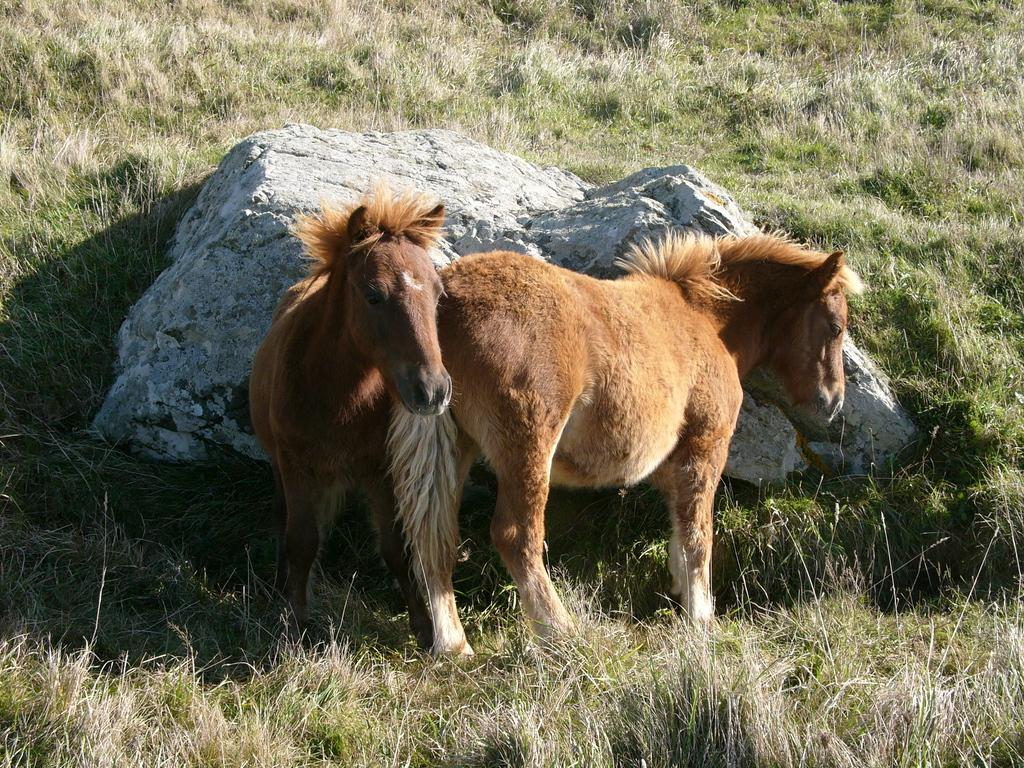How many horses are in the image? There are two horses in the image. What is the surface the horses are standing on? The horses are on the grass. What object are the horses leaning on? The horses are leaning on a rock. What type of advertisement can be seen on the horses in the image? There is no advertisement present on the horses in the image. What sound do the bells make that are attached to the horses in the image? There are no bells attached to the horses in the image. 